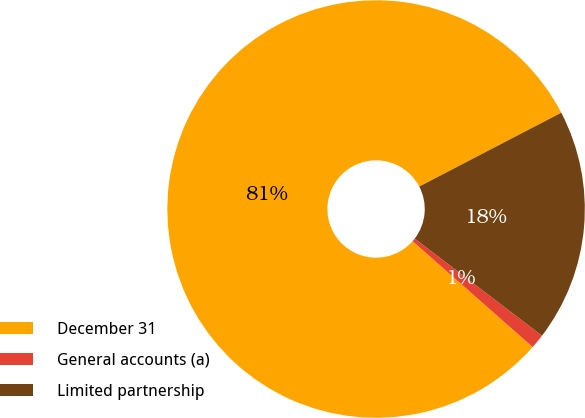<chart> <loc_0><loc_0><loc_500><loc_500><pie_chart><fcel>December 31<fcel>General accounts (a)<fcel>Limited partnership<nl><fcel>80.87%<fcel>1.12%<fcel>18.01%<nl></chart> 